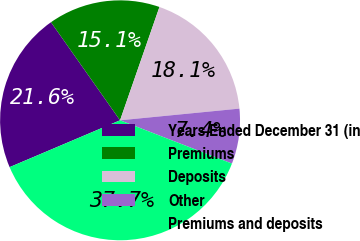Convert chart. <chart><loc_0><loc_0><loc_500><loc_500><pie_chart><fcel>Years Ended December 31 (in<fcel>Premiums<fcel>Deposits<fcel>Other<fcel>Premiums and deposits<nl><fcel>21.62%<fcel>15.09%<fcel>18.12%<fcel>7.43%<fcel>37.74%<nl></chart> 